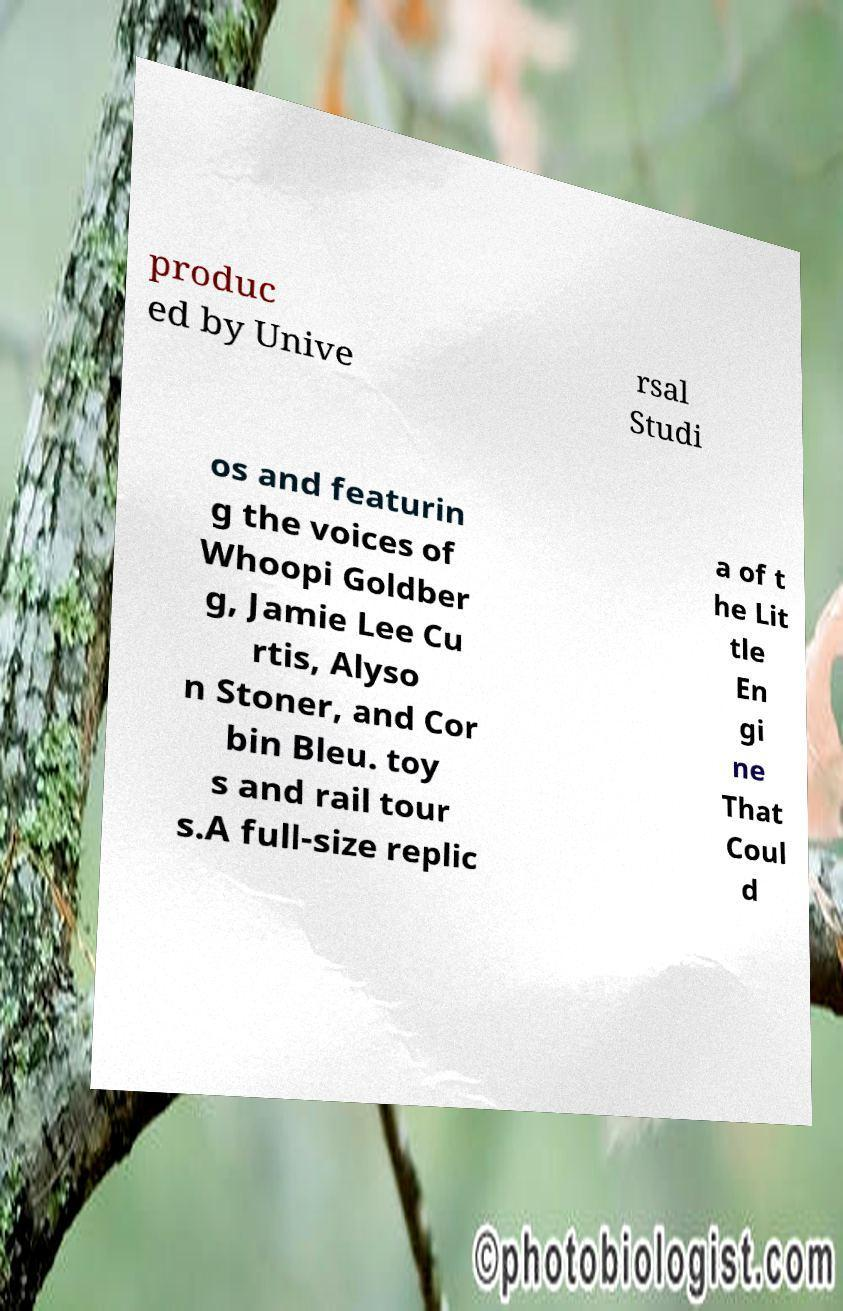Please read and relay the text visible in this image. What does it say? produc ed by Unive rsal Studi os and featurin g the voices of Whoopi Goldber g, Jamie Lee Cu rtis, Alyso n Stoner, and Cor bin Bleu. toy s and rail tour s.A full-size replic a of t he Lit tle En gi ne That Coul d 